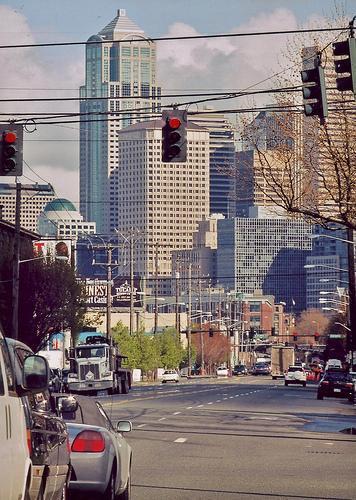How many red stoplights are there?
Give a very brief answer. 2. 